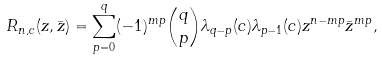<formula> <loc_0><loc_0><loc_500><loc_500>R _ { n , c } ( z , \bar { z } ) = \sum _ { p = 0 } ^ { q } ( - 1 ) ^ { m p } \binom { q } { p } \lambda _ { q - p } ( c ) \lambda _ { p - 1 } ( c ) z ^ { n - m p } \bar { z } ^ { m p } ,</formula> 